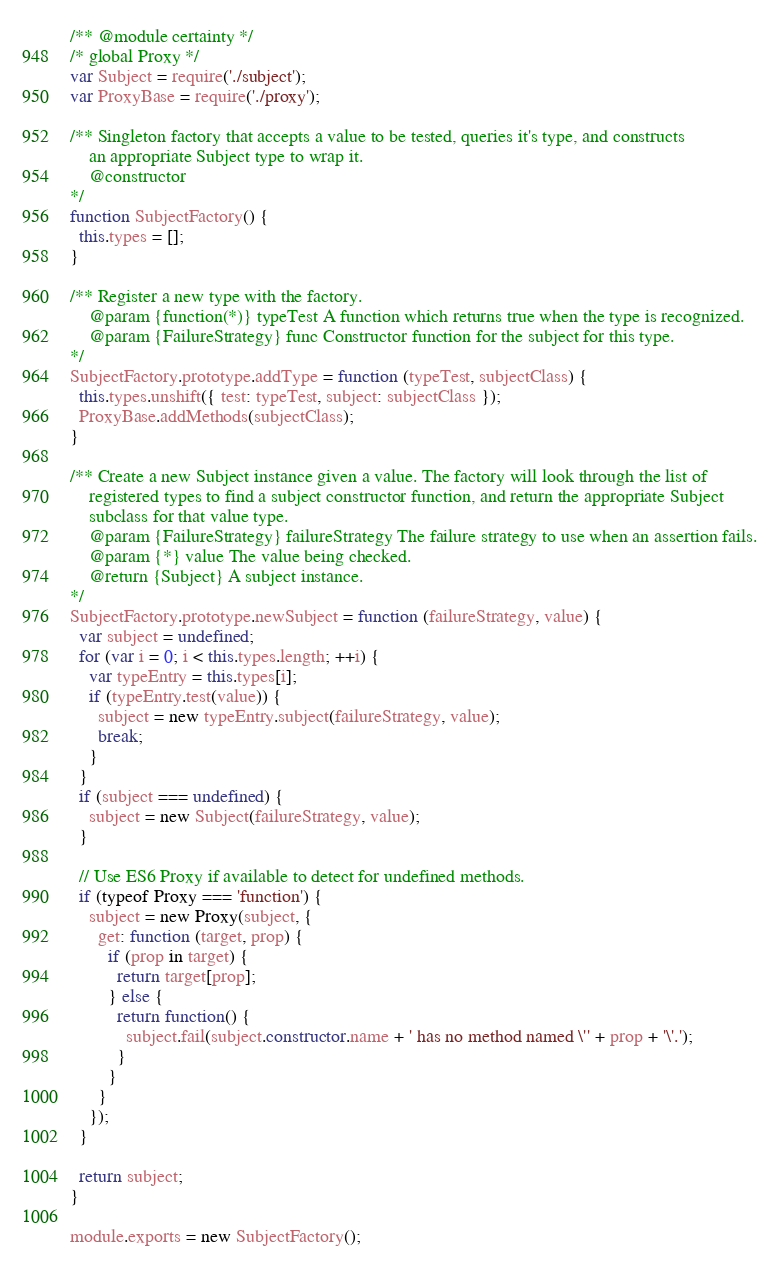Convert code to text. <code><loc_0><loc_0><loc_500><loc_500><_JavaScript_>/** @module certainty */
/* global Proxy */
var Subject = require('./subject');
var ProxyBase = require('./proxy');

/** Singleton factory that accepts a value to be tested, queries it's type, and constructs
    an appropriate Subject type to wrap it.
    @constructor
*/
function SubjectFactory() {
  this.types = [];
}

/** Register a new type with the factory.
    @param {function(*)} typeTest A function which returns true when the type is recognized.
    @param {FailureStrategy} func Constructor function for the subject for this type.
*/
SubjectFactory.prototype.addType = function (typeTest, subjectClass) {
  this.types.unshift({ test: typeTest, subject: subjectClass });
  ProxyBase.addMethods(subjectClass);
}

/** Create a new Subject instance given a value. The factory will look through the list of
    registered types to find a subject constructor function, and return the appropriate Subject
    subclass for that value type.
    @param {FailureStrategy} failureStrategy The failure strategy to use when an assertion fails.
    @param {*} value The value being checked.
    @return {Subject} A subject instance.
*/
SubjectFactory.prototype.newSubject = function (failureStrategy, value) {
  var subject = undefined;
  for (var i = 0; i < this.types.length; ++i) {
    var typeEntry = this.types[i];
    if (typeEntry.test(value)) {
      subject = new typeEntry.subject(failureStrategy, value);
      break;
    }
  }
  if (subject === undefined) {
    subject = new Subject(failureStrategy, value);
  }

  // Use ES6 Proxy if available to detect for undefined methods.
  if (typeof Proxy === 'function') {
    subject = new Proxy(subject, {
      get: function (target, prop) {
        if (prop in target) {
          return target[prop];
        } else {
          return function() {
            subject.fail(subject.constructor.name + ' has no method named \'' + prop + '\'.');
          }
        }
      }
    });
  }

  return subject;
}

module.exports = new SubjectFactory();
</code> 